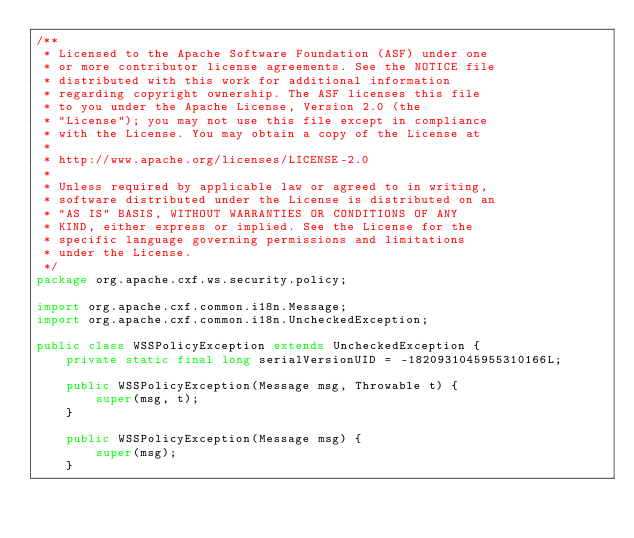Convert code to text. <code><loc_0><loc_0><loc_500><loc_500><_Java_>/**
 * Licensed to the Apache Software Foundation (ASF) under one
 * or more contributor license agreements. See the NOTICE file
 * distributed with this work for additional information
 * regarding copyright ownership. The ASF licenses this file
 * to you under the Apache License, Version 2.0 (the
 * "License"); you may not use this file except in compliance
 * with the License. You may obtain a copy of the License at
 *
 * http://www.apache.org/licenses/LICENSE-2.0
 *
 * Unless required by applicable law or agreed to in writing,
 * software distributed under the License is distributed on an
 * "AS IS" BASIS, WITHOUT WARRANTIES OR CONDITIONS OF ANY
 * KIND, either express or implied. See the License for the
 * specific language governing permissions and limitations
 * under the License.
 */
package org.apache.cxf.ws.security.policy;

import org.apache.cxf.common.i18n.Message;
import org.apache.cxf.common.i18n.UncheckedException;

public class WSSPolicyException extends UncheckedException {
    private static final long serialVersionUID = -1820931045955310166L;

    public WSSPolicyException(Message msg, Throwable t) {
        super(msg, t);
    }

    public WSSPolicyException(Message msg) {
        super(msg);
    }
</code> 